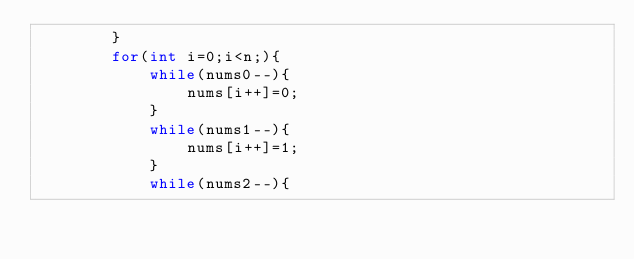Convert code to text. <code><loc_0><loc_0><loc_500><loc_500><_C++_>        }
        for(int i=0;i<n;){
            while(nums0--){
                nums[i++]=0;
            }
            while(nums1--){
                nums[i++]=1;
            }
            while(nums2--){</code> 